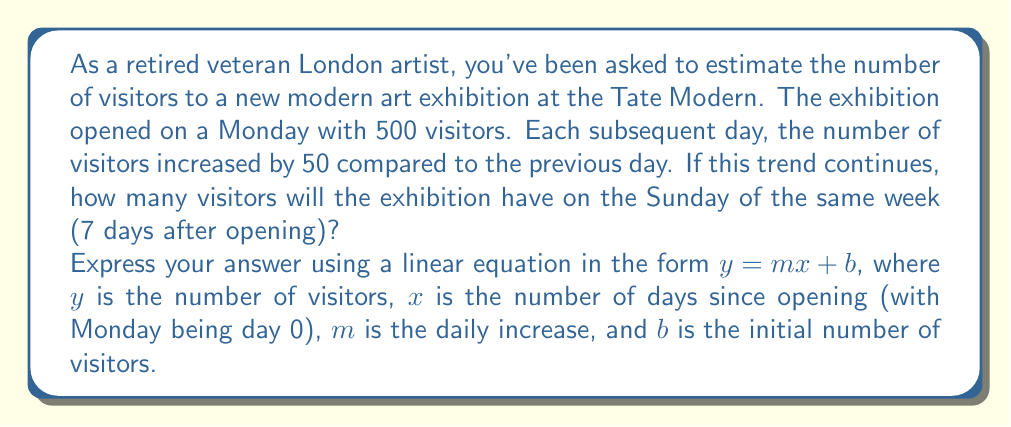Could you help me with this problem? Let's approach this step-by-step:

1) We're dealing with a linear growth pattern, where:
   - The initial number of visitors (b) is 500
   - The daily increase (m) is 50

2) We can express this as a linear equation:
   $y = 50x + 500$

   Where:
   $y$ = number of visitors
   $x$ = number of days since opening (Monday is day 0)
   50 = daily increase
   500 = initial number of visitors

3) To find the number of visitors on Sunday, we need to calculate for $x = 6$ (as Sunday is the 7th day, but we start counting from 0):

   $y = 50(6) + 500$

4) Let's solve this equation:
   $y = 300 + 500 = 800$

Therefore, on Sunday, the exhibition is estimated to have 800 visitors.

5) To verify, let's list out each day:
   Monday ($x=0$): $y = 50(0) + 500 = 500$
   Tuesday ($x=1$): $y = 50(1) + 500 = 550$
   Wednesday ($x=2$): $y = 50(2) + 500 = 600$
   Thursday ($x=3$): $y = 50(3) + 500 = 650$
   Friday ($x=4$): $y = 50(4) + 500 = 700$
   Saturday ($x=5$): $y = 50(5) + 500 = 750$
   Sunday ($x=6$): $y = 50(6) + 500 = 800$

This confirms our calculation.
Answer: $y = 50x + 500$, where $y$ is the number of visitors and $x$ is the number of days since opening. On Sunday ($x=6$), the exhibition will have 800 visitors. 